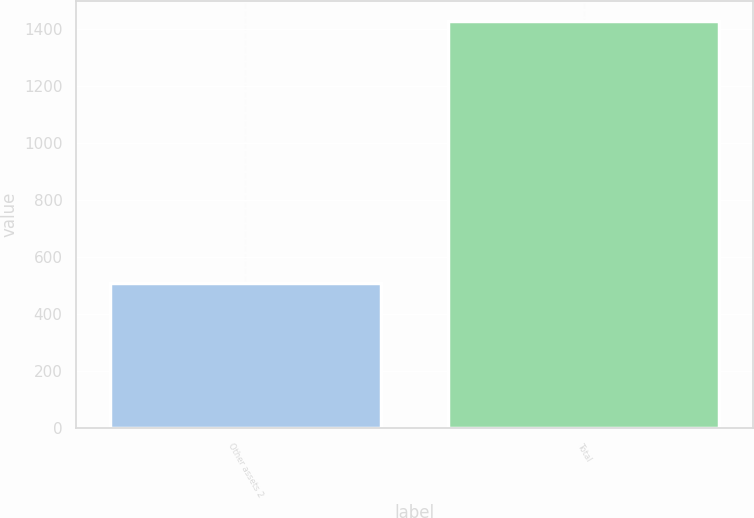<chart> <loc_0><loc_0><loc_500><loc_500><bar_chart><fcel>Other assets 2<fcel>Total<nl><fcel>507<fcel>1426<nl></chart> 